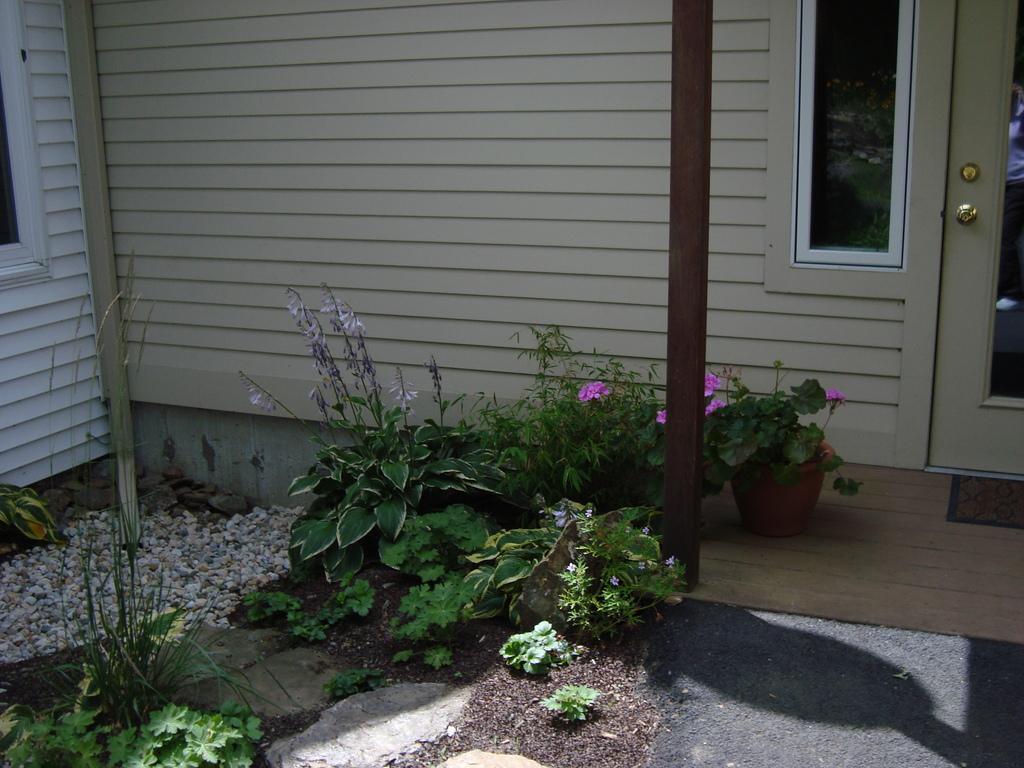In one or two sentences, can you explain what this image depicts? In the background we can see the partial part of a door. In this picture we can see glass window, wall, bolt. We can see the plants, pot, pole, door mat, pebbles. 